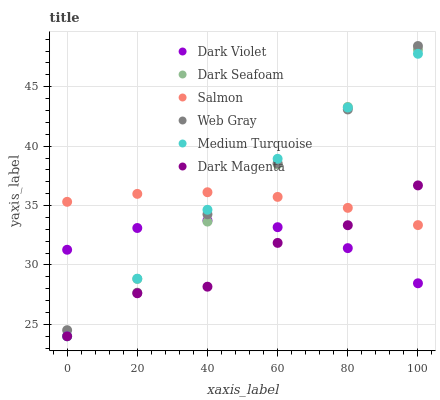Does Dark Magenta have the minimum area under the curve?
Answer yes or no. Yes. Does Medium Turquoise have the maximum area under the curve?
Answer yes or no. Yes. Does Salmon have the minimum area under the curve?
Answer yes or no. No. Does Salmon have the maximum area under the curve?
Answer yes or no. No. Is Dark Seafoam the smoothest?
Answer yes or no. Yes. Is Dark Magenta the roughest?
Answer yes or no. Yes. Is Salmon the smoothest?
Answer yes or no. No. Is Salmon the roughest?
Answer yes or no. No. Does Dark Magenta have the lowest value?
Answer yes or no. Yes. Does Salmon have the lowest value?
Answer yes or no. No. Does Web Gray have the highest value?
Answer yes or no. Yes. Does Dark Magenta have the highest value?
Answer yes or no. No. Is Dark Magenta less than Web Gray?
Answer yes or no. Yes. Is Salmon greater than Dark Violet?
Answer yes or no. Yes. Does Web Gray intersect Salmon?
Answer yes or no. Yes. Is Web Gray less than Salmon?
Answer yes or no. No. Is Web Gray greater than Salmon?
Answer yes or no. No. Does Dark Magenta intersect Web Gray?
Answer yes or no. No. 